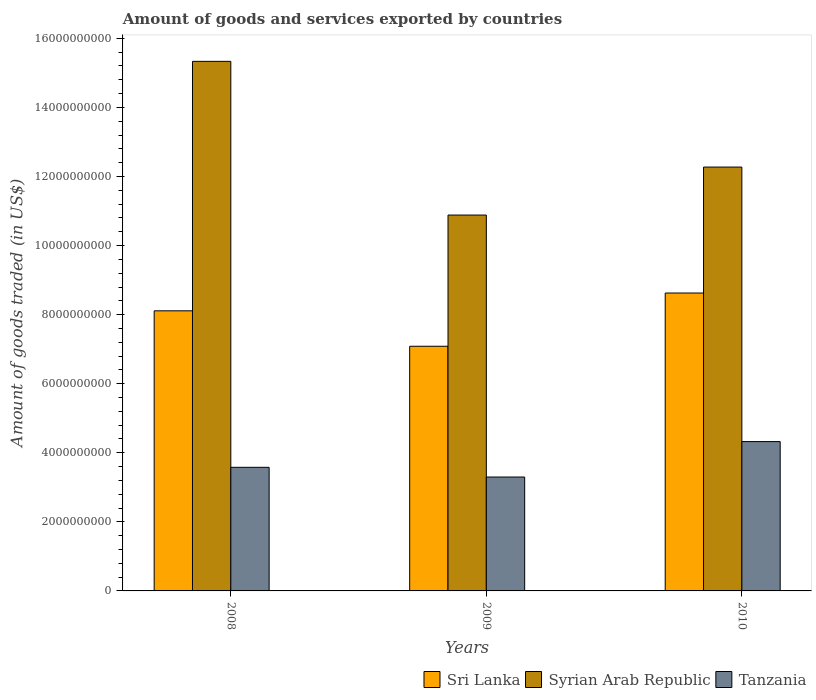How many different coloured bars are there?
Your answer should be compact. 3. How many groups of bars are there?
Ensure brevity in your answer.  3. Are the number of bars per tick equal to the number of legend labels?
Your answer should be very brief. Yes. How many bars are there on the 1st tick from the right?
Your answer should be compact. 3. In how many cases, is the number of bars for a given year not equal to the number of legend labels?
Make the answer very short. 0. What is the total amount of goods and services exported in Sri Lanka in 2008?
Your answer should be compact. 8.11e+09. Across all years, what is the maximum total amount of goods and services exported in Syrian Arab Republic?
Your answer should be very brief. 1.53e+1. Across all years, what is the minimum total amount of goods and services exported in Syrian Arab Republic?
Offer a very short reply. 1.09e+1. In which year was the total amount of goods and services exported in Tanzania maximum?
Keep it short and to the point. 2010. In which year was the total amount of goods and services exported in Syrian Arab Republic minimum?
Your response must be concise. 2009. What is the total total amount of goods and services exported in Syrian Arab Republic in the graph?
Keep it short and to the point. 3.85e+1. What is the difference between the total amount of goods and services exported in Tanzania in 2008 and that in 2009?
Your answer should be compact. 2.81e+08. What is the difference between the total amount of goods and services exported in Sri Lanka in 2008 and the total amount of goods and services exported in Syrian Arab Republic in 2009?
Keep it short and to the point. -2.77e+09. What is the average total amount of goods and services exported in Tanzania per year?
Ensure brevity in your answer.  3.73e+09. In the year 2008, what is the difference between the total amount of goods and services exported in Sri Lanka and total amount of goods and services exported in Tanzania?
Provide a short and direct response. 4.53e+09. What is the ratio of the total amount of goods and services exported in Tanzania in 2009 to that in 2010?
Your response must be concise. 0.76. Is the total amount of goods and services exported in Sri Lanka in 2008 less than that in 2009?
Offer a terse response. No. Is the difference between the total amount of goods and services exported in Sri Lanka in 2008 and 2010 greater than the difference between the total amount of goods and services exported in Tanzania in 2008 and 2010?
Provide a short and direct response. Yes. What is the difference between the highest and the second highest total amount of goods and services exported in Tanzania?
Provide a short and direct response. 7.45e+08. What is the difference between the highest and the lowest total amount of goods and services exported in Sri Lanka?
Your answer should be very brief. 1.54e+09. In how many years, is the total amount of goods and services exported in Syrian Arab Republic greater than the average total amount of goods and services exported in Syrian Arab Republic taken over all years?
Your answer should be very brief. 1. What does the 3rd bar from the left in 2008 represents?
Provide a succinct answer. Tanzania. What does the 2nd bar from the right in 2010 represents?
Ensure brevity in your answer.  Syrian Arab Republic. Are all the bars in the graph horizontal?
Provide a succinct answer. No. How many years are there in the graph?
Make the answer very short. 3. What is the difference between two consecutive major ticks on the Y-axis?
Your response must be concise. 2.00e+09. Does the graph contain any zero values?
Offer a very short reply. No. What is the title of the graph?
Your answer should be very brief. Amount of goods and services exported by countries. What is the label or title of the Y-axis?
Ensure brevity in your answer.  Amount of goods traded (in US$). What is the Amount of goods traded (in US$) in Sri Lanka in 2008?
Your answer should be very brief. 8.11e+09. What is the Amount of goods traded (in US$) in Syrian Arab Republic in 2008?
Give a very brief answer. 1.53e+1. What is the Amount of goods traded (in US$) of Tanzania in 2008?
Offer a terse response. 3.58e+09. What is the Amount of goods traded (in US$) of Sri Lanka in 2009?
Your response must be concise. 7.08e+09. What is the Amount of goods traded (in US$) of Syrian Arab Republic in 2009?
Provide a succinct answer. 1.09e+1. What is the Amount of goods traded (in US$) in Tanzania in 2009?
Provide a succinct answer. 3.30e+09. What is the Amount of goods traded (in US$) in Sri Lanka in 2010?
Your answer should be compact. 8.63e+09. What is the Amount of goods traded (in US$) in Syrian Arab Republic in 2010?
Give a very brief answer. 1.23e+1. What is the Amount of goods traded (in US$) of Tanzania in 2010?
Provide a short and direct response. 4.32e+09. Across all years, what is the maximum Amount of goods traded (in US$) of Sri Lanka?
Give a very brief answer. 8.63e+09. Across all years, what is the maximum Amount of goods traded (in US$) of Syrian Arab Republic?
Your answer should be very brief. 1.53e+1. Across all years, what is the maximum Amount of goods traded (in US$) of Tanzania?
Provide a succinct answer. 4.32e+09. Across all years, what is the minimum Amount of goods traded (in US$) in Sri Lanka?
Provide a succinct answer. 7.08e+09. Across all years, what is the minimum Amount of goods traded (in US$) of Syrian Arab Republic?
Your answer should be compact. 1.09e+1. Across all years, what is the minimum Amount of goods traded (in US$) in Tanzania?
Give a very brief answer. 3.30e+09. What is the total Amount of goods traded (in US$) in Sri Lanka in the graph?
Keep it short and to the point. 2.38e+1. What is the total Amount of goods traded (in US$) of Syrian Arab Republic in the graph?
Your answer should be very brief. 3.85e+1. What is the total Amount of goods traded (in US$) in Tanzania in the graph?
Provide a succinct answer. 1.12e+1. What is the difference between the Amount of goods traded (in US$) of Sri Lanka in 2008 and that in 2009?
Provide a succinct answer. 1.03e+09. What is the difference between the Amount of goods traded (in US$) in Syrian Arab Republic in 2008 and that in 2009?
Your answer should be very brief. 4.45e+09. What is the difference between the Amount of goods traded (in US$) in Tanzania in 2008 and that in 2009?
Offer a very short reply. 2.81e+08. What is the difference between the Amount of goods traded (in US$) of Sri Lanka in 2008 and that in 2010?
Your answer should be very brief. -5.15e+08. What is the difference between the Amount of goods traded (in US$) in Syrian Arab Republic in 2008 and that in 2010?
Provide a short and direct response. 3.06e+09. What is the difference between the Amount of goods traded (in US$) of Tanzania in 2008 and that in 2010?
Give a very brief answer. -7.45e+08. What is the difference between the Amount of goods traded (in US$) of Sri Lanka in 2009 and that in 2010?
Your answer should be compact. -1.54e+09. What is the difference between the Amount of goods traded (in US$) in Syrian Arab Republic in 2009 and that in 2010?
Your response must be concise. -1.39e+09. What is the difference between the Amount of goods traded (in US$) in Tanzania in 2009 and that in 2010?
Provide a short and direct response. -1.03e+09. What is the difference between the Amount of goods traded (in US$) in Sri Lanka in 2008 and the Amount of goods traded (in US$) in Syrian Arab Republic in 2009?
Offer a very short reply. -2.77e+09. What is the difference between the Amount of goods traded (in US$) of Sri Lanka in 2008 and the Amount of goods traded (in US$) of Tanzania in 2009?
Make the answer very short. 4.81e+09. What is the difference between the Amount of goods traded (in US$) of Syrian Arab Republic in 2008 and the Amount of goods traded (in US$) of Tanzania in 2009?
Your answer should be compact. 1.20e+1. What is the difference between the Amount of goods traded (in US$) in Sri Lanka in 2008 and the Amount of goods traded (in US$) in Syrian Arab Republic in 2010?
Offer a terse response. -4.16e+09. What is the difference between the Amount of goods traded (in US$) in Sri Lanka in 2008 and the Amount of goods traded (in US$) in Tanzania in 2010?
Your response must be concise. 3.79e+09. What is the difference between the Amount of goods traded (in US$) of Syrian Arab Republic in 2008 and the Amount of goods traded (in US$) of Tanzania in 2010?
Make the answer very short. 1.10e+1. What is the difference between the Amount of goods traded (in US$) in Sri Lanka in 2009 and the Amount of goods traded (in US$) in Syrian Arab Republic in 2010?
Offer a terse response. -5.19e+09. What is the difference between the Amount of goods traded (in US$) in Sri Lanka in 2009 and the Amount of goods traded (in US$) in Tanzania in 2010?
Offer a very short reply. 2.76e+09. What is the difference between the Amount of goods traded (in US$) of Syrian Arab Republic in 2009 and the Amount of goods traded (in US$) of Tanzania in 2010?
Provide a succinct answer. 6.56e+09. What is the average Amount of goods traded (in US$) in Sri Lanka per year?
Provide a short and direct response. 7.94e+09. What is the average Amount of goods traded (in US$) in Syrian Arab Republic per year?
Your response must be concise. 1.28e+1. What is the average Amount of goods traded (in US$) of Tanzania per year?
Provide a short and direct response. 3.73e+09. In the year 2008, what is the difference between the Amount of goods traded (in US$) of Sri Lanka and Amount of goods traded (in US$) of Syrian Arab Republic?
Your answer should be compact. -7.22e+09. In the year 2008, what is the difference between the Amount of goods traded (in US$) of Sri Lanka and Amount of goods traded (in US$) of Tanzania?
Give a very brief answer. 4.53e+09. In the year 2008, what is the difference between the Amount of goods traded (in US$) in Syrian Arab Republic and Amount of goods traded (in US$) in Tanzania?
Ensure brevity in your answer.  1.18e+1. In the year 2009, what is the difference between the Amount of goods traded (in US$) of Sri Lanka and Amount of goods traded (in US$) of Syrian Arab Republic?
Your answer should be compact. -3.80e+09. In the year 2009, what is the difference between the Amount of goods traded (in US$) in Sri Lanka and Amount of goods traded (in US$) in Tanzania?
Ensure brevity in your answer.  3.79e+09. In the year 2009, what is the difference between the Amount of goods traded (in US$) in Syrian Arab Republic and Amount of goods traded (in US$) in Tanzania?
Ensure brevity in your answer.  7.59e+09. In the year 2010, what is the difference between the Amount of goods traded (in US$) in Sri Lanka and Amount of goods traded (in US$) in Syrian Arab Republic?
Ensure brevity in your answer.  -3.65e+09. In the year 2010, what is the difference between the Amount of goods traded (in US$) in Sri Lanka and Amount of goods traded (in US$) in Tanzania?
Keep it short and to the point. 4.30e+09. In the year 2010, what is the difference between the Amount of goods traded (in US$) of Syrian Arab Republic and Amount of goods traded (in US$) of Tanzania?
Ensure brevity in your answer.  7.95e+09. What is the ratio of the Amount of goods traded (in US$) of Sri Lanka in 2008 to that in 2009?
Keep it short and to the point. 1.14. What is the ratio of the Amount of goods traded (in US$) of Syrian Arab Republic in 2008 to that in 2009?
Offer a terse response. 1.41. What is the ratio of the Amount of goods traded (in US$) in Tanzania in 2008 to that in 2009?
Your answer should be compact. 1.09. What is the ratio of the Amount of goods traded (in US$) of Sri Lanka in 2008 to that in 2010?
Offer a terse response. 0.94. What is the ratio of the Amount of goods traded (in US$) in Syrian Arab Republic in 2008 to that in 2010?
Your answer should be compact. 1.25. What is the ratio of the Amount of goods traded (in US$) of Tanzania in 2008 to that in 2010?
Your answer should be very brief. 0.83. What is the ratio of the Amount of goods traded (in US$) of Sri Lanka in 2009 to that in 2010?
Provide a short and direct response. 0.82. What is the ratio of the Amount of goods traded (in US$) of Syrian Arab Republic in 2009 to that in 2010?
Ensure brevity in your answer.  0.89. What is the ratio of the Amount of goods traded (in US$) in Tanzania in 2009 to that in 2010?
Provide a short and direct response. 0.76. What is the difference between the highest and the second highest Amount of goods traded (in US$) of Sri Lanka?
Your response must be concise. 5.15e+08. What is the difference between the highest and the second highest Amount of goods traded (in US$) of Syrian Arab Republic?
Your answer should be compact. 3.06e+09. What is the difference between the highest and the second highest Amount of goods traded (in US$) of Tanzania?
Provide a succinct answer. 7.45e+08. What is the difference between the highest and the lowest Amount of goods traded (in US$) in Sri Lanka?
Provide a succinct answer. 1.54e+09. What is the difference between the highest and the lowest Amount of goods traded (in US$) in Syrian Arab Republic?
Offer a terse response. 4.45e+09. What is the difference between the highest and the lowest Amount of goods traded (in US$) of Tanzania?
Offer a terse response. 1.03e+09. 